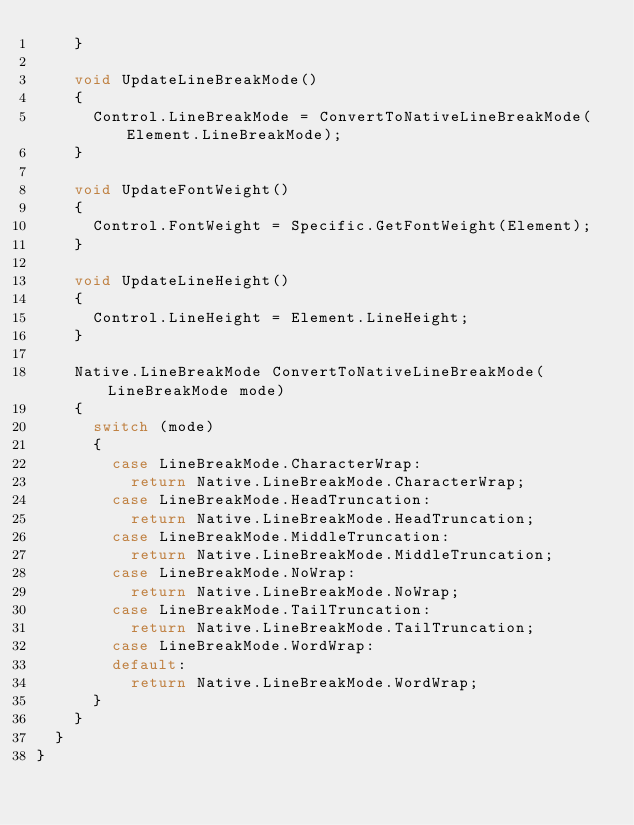Convert code to text. <code><loc_0><loc_0><loc_500><loc_500><_C#_>		}

		void UpdateLineBreakMode()
		{
			Control.LineBreakMode = ConvertToNativeLineBreakMode(Element.LineBreakMode);
		}

		void UpdateFontWeight()
		{
			Control.FontWeight = Specific.GetFontWeight(Element);
		}

		void UpdateLineHeight()
		{
			Control.LineHeight = Element.LineHeight;
		}

		Native.LineBreakMode ConvertToNativeLineBreakMode(LineBreakMode mode)
		{
			switch (mode)
			{
				case LineBreakMode.CharacterWrap:
					return Native.LineBreakMode.CharacterWrap;
				case LineBreakMode.HeadTruncation:
					return Native.LineBreakMode.HeadTruncation;
				case LineBreakMode.MiddleTruncation:
					return Native.LineBreakMode.MiddleTruncation;
				case LineBreakMode.NoWrap:
					return Native.LineBreakMode.NoWrap;
				case LineBreakMode.TailTruncation:
					return Native.LineBreakMode.TailTruncation;
				case LineBreakMode.WordWrap:
				default:
					return Native.LineBreakMode.WordWrap;
			}
		}
	}
}
</code> 